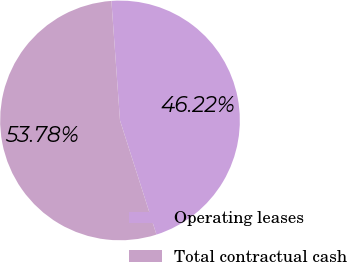Convert chart to OTSL. <chart><loc_0><loc_0><loc_500><loc_500><pie_chart><fcel>Operating leases<fcel>Total contractual cash<nl><fcel>46.22%<fcel>53.78%<nl></chart> 